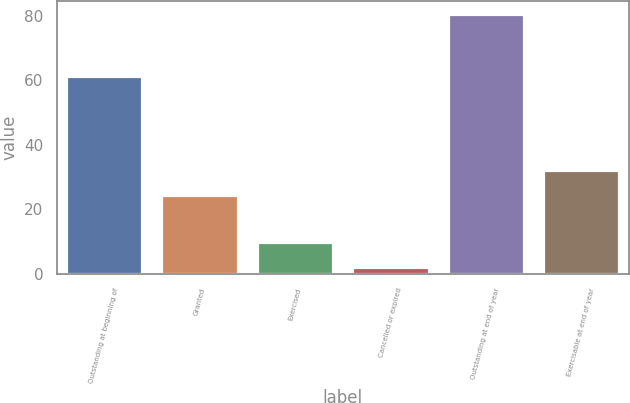Convert chart. <chart><loc_0><loc_0><loc_500><loc_500><bar_chart><fcel>Outstanding at beginning of<fcel>Granted<fcel>Exercised<fcel>Cancelled or expired<fcel>Outstanding at end of year<fcel>Exercisable at end of year<nl><fcel>61.4<fcel>24.5<fcel>10.02<fcel>2.2<fcel>80.4<fcel>32.32<nl></chart> 